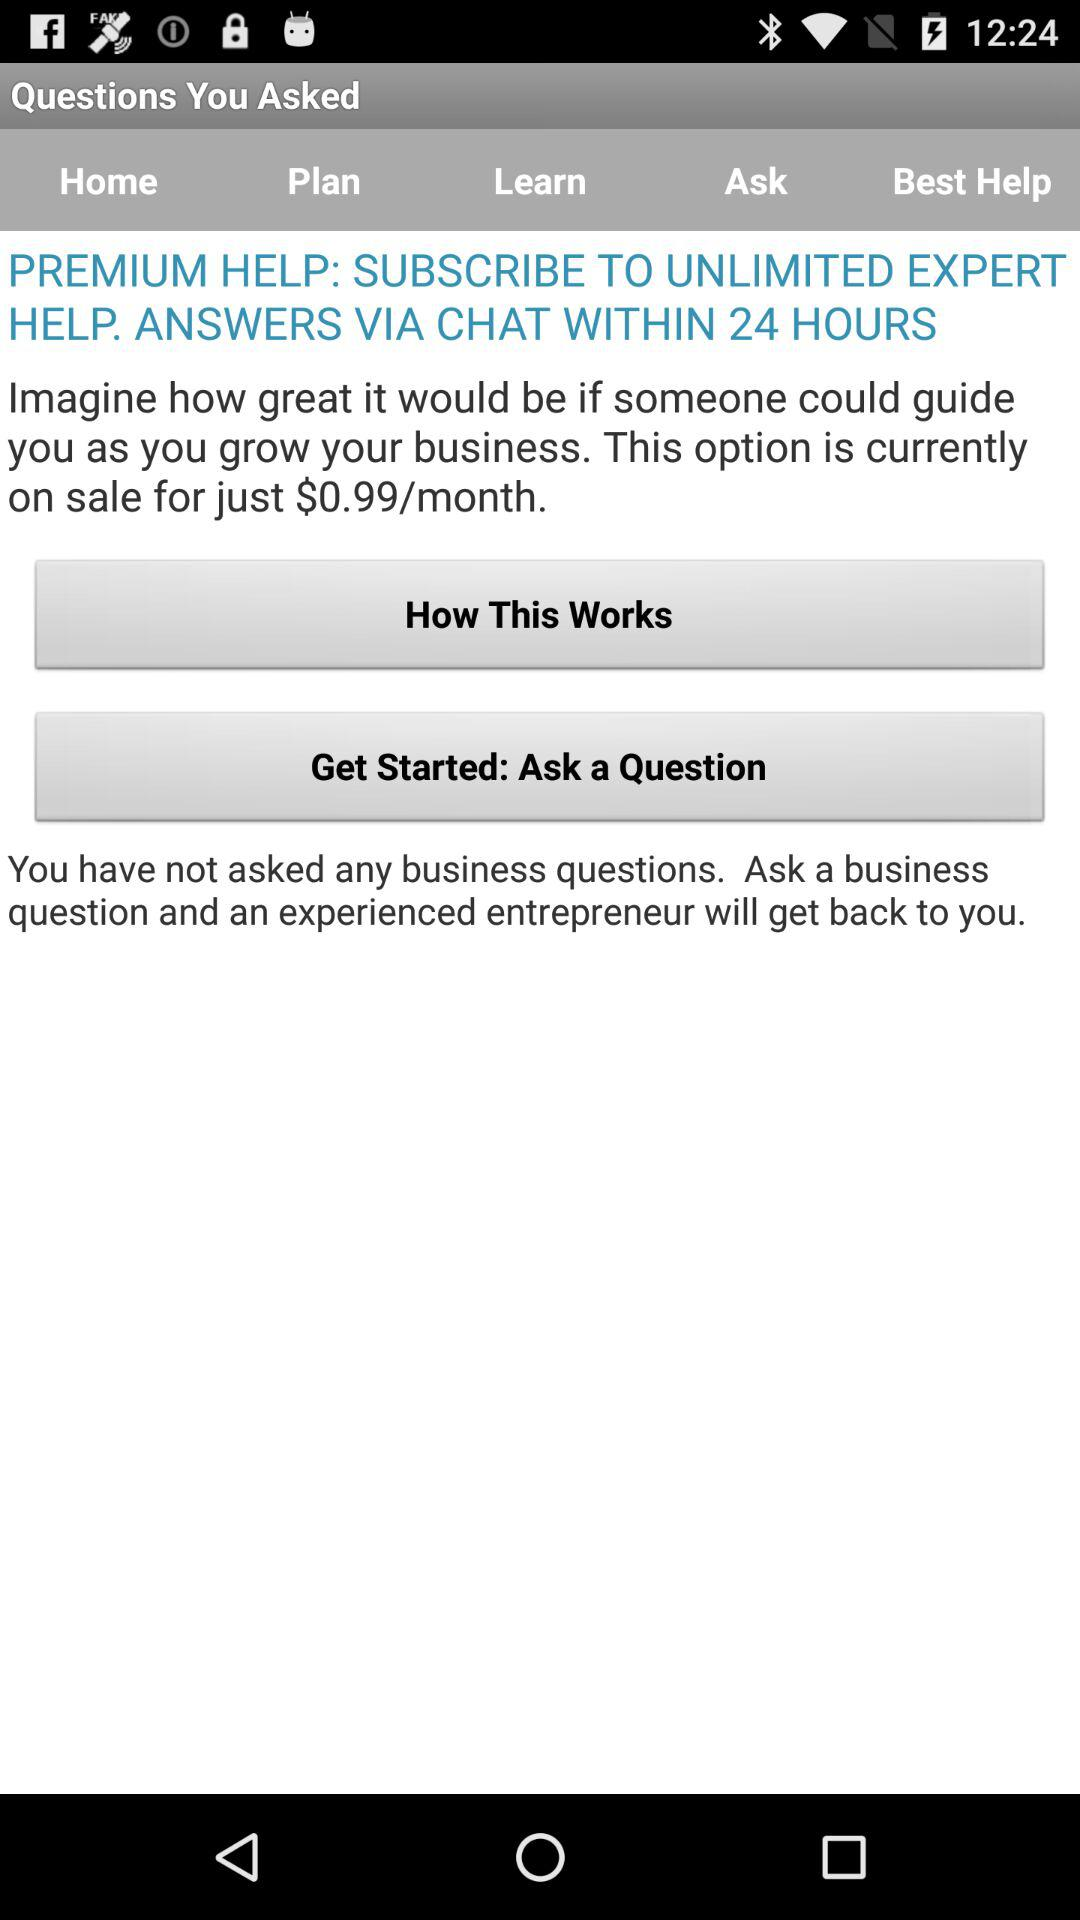How many questions have I asked?
Answer the question using a single word or phrase. 0 